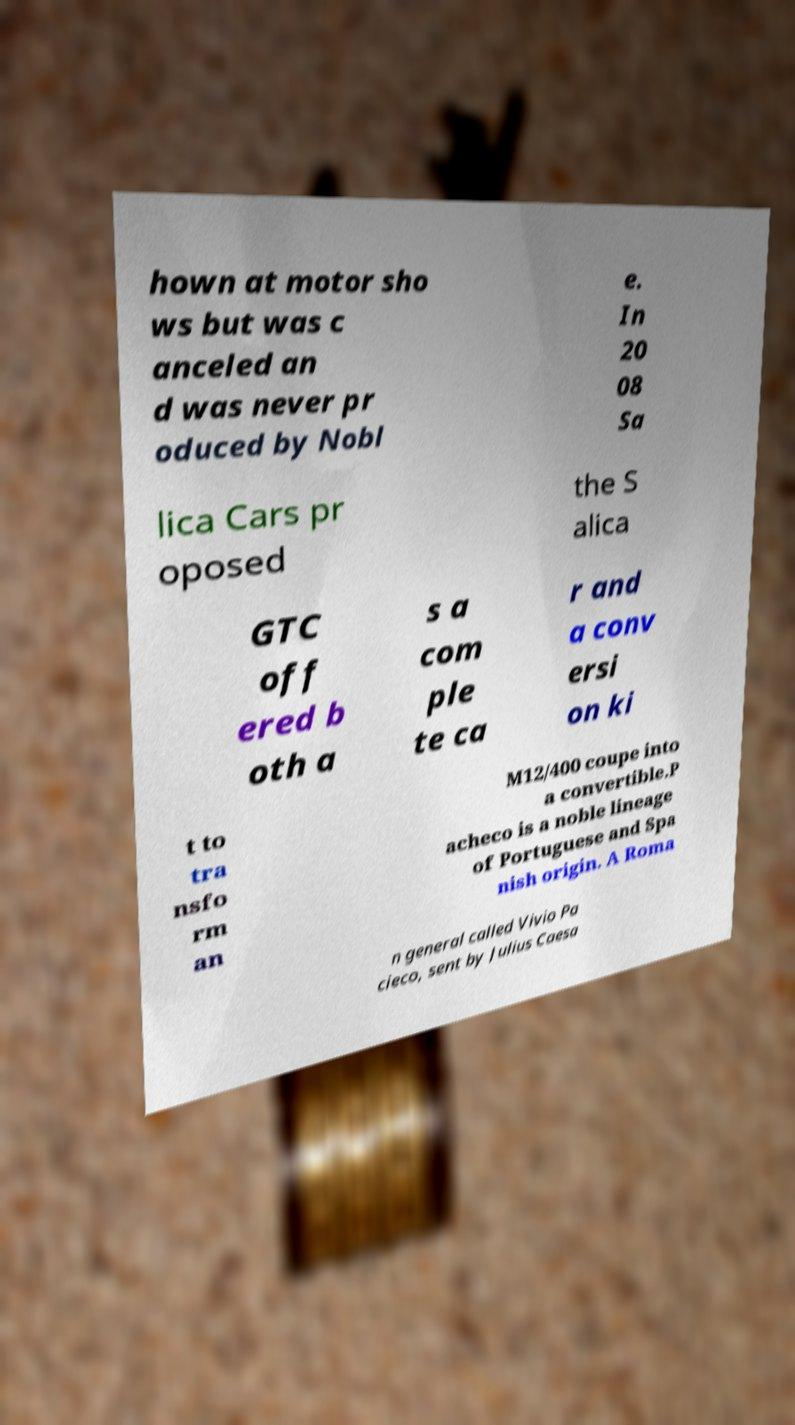Can you accurately transcribe the text from the provided image for me? hown at motor sho ws but was c anceled an d was never pr oduced by Nobl e. In 20 08 Sa lica Cars pr oposed the S alica GTC off ered b oth a s a com ple te ca r and a conv ersi on ki t to tra nsfo rm an M12/400 coupe into a convertible.P acheco is a noble lineage of Portuguese and Spa nish origin. A Roma n general called Vivio Pa cieco, sent by Julius Caesa 